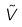Convert formula to latex. <formula><loc_0><loc_0><loc_500><loc_500>\tilde { V }</formula> 